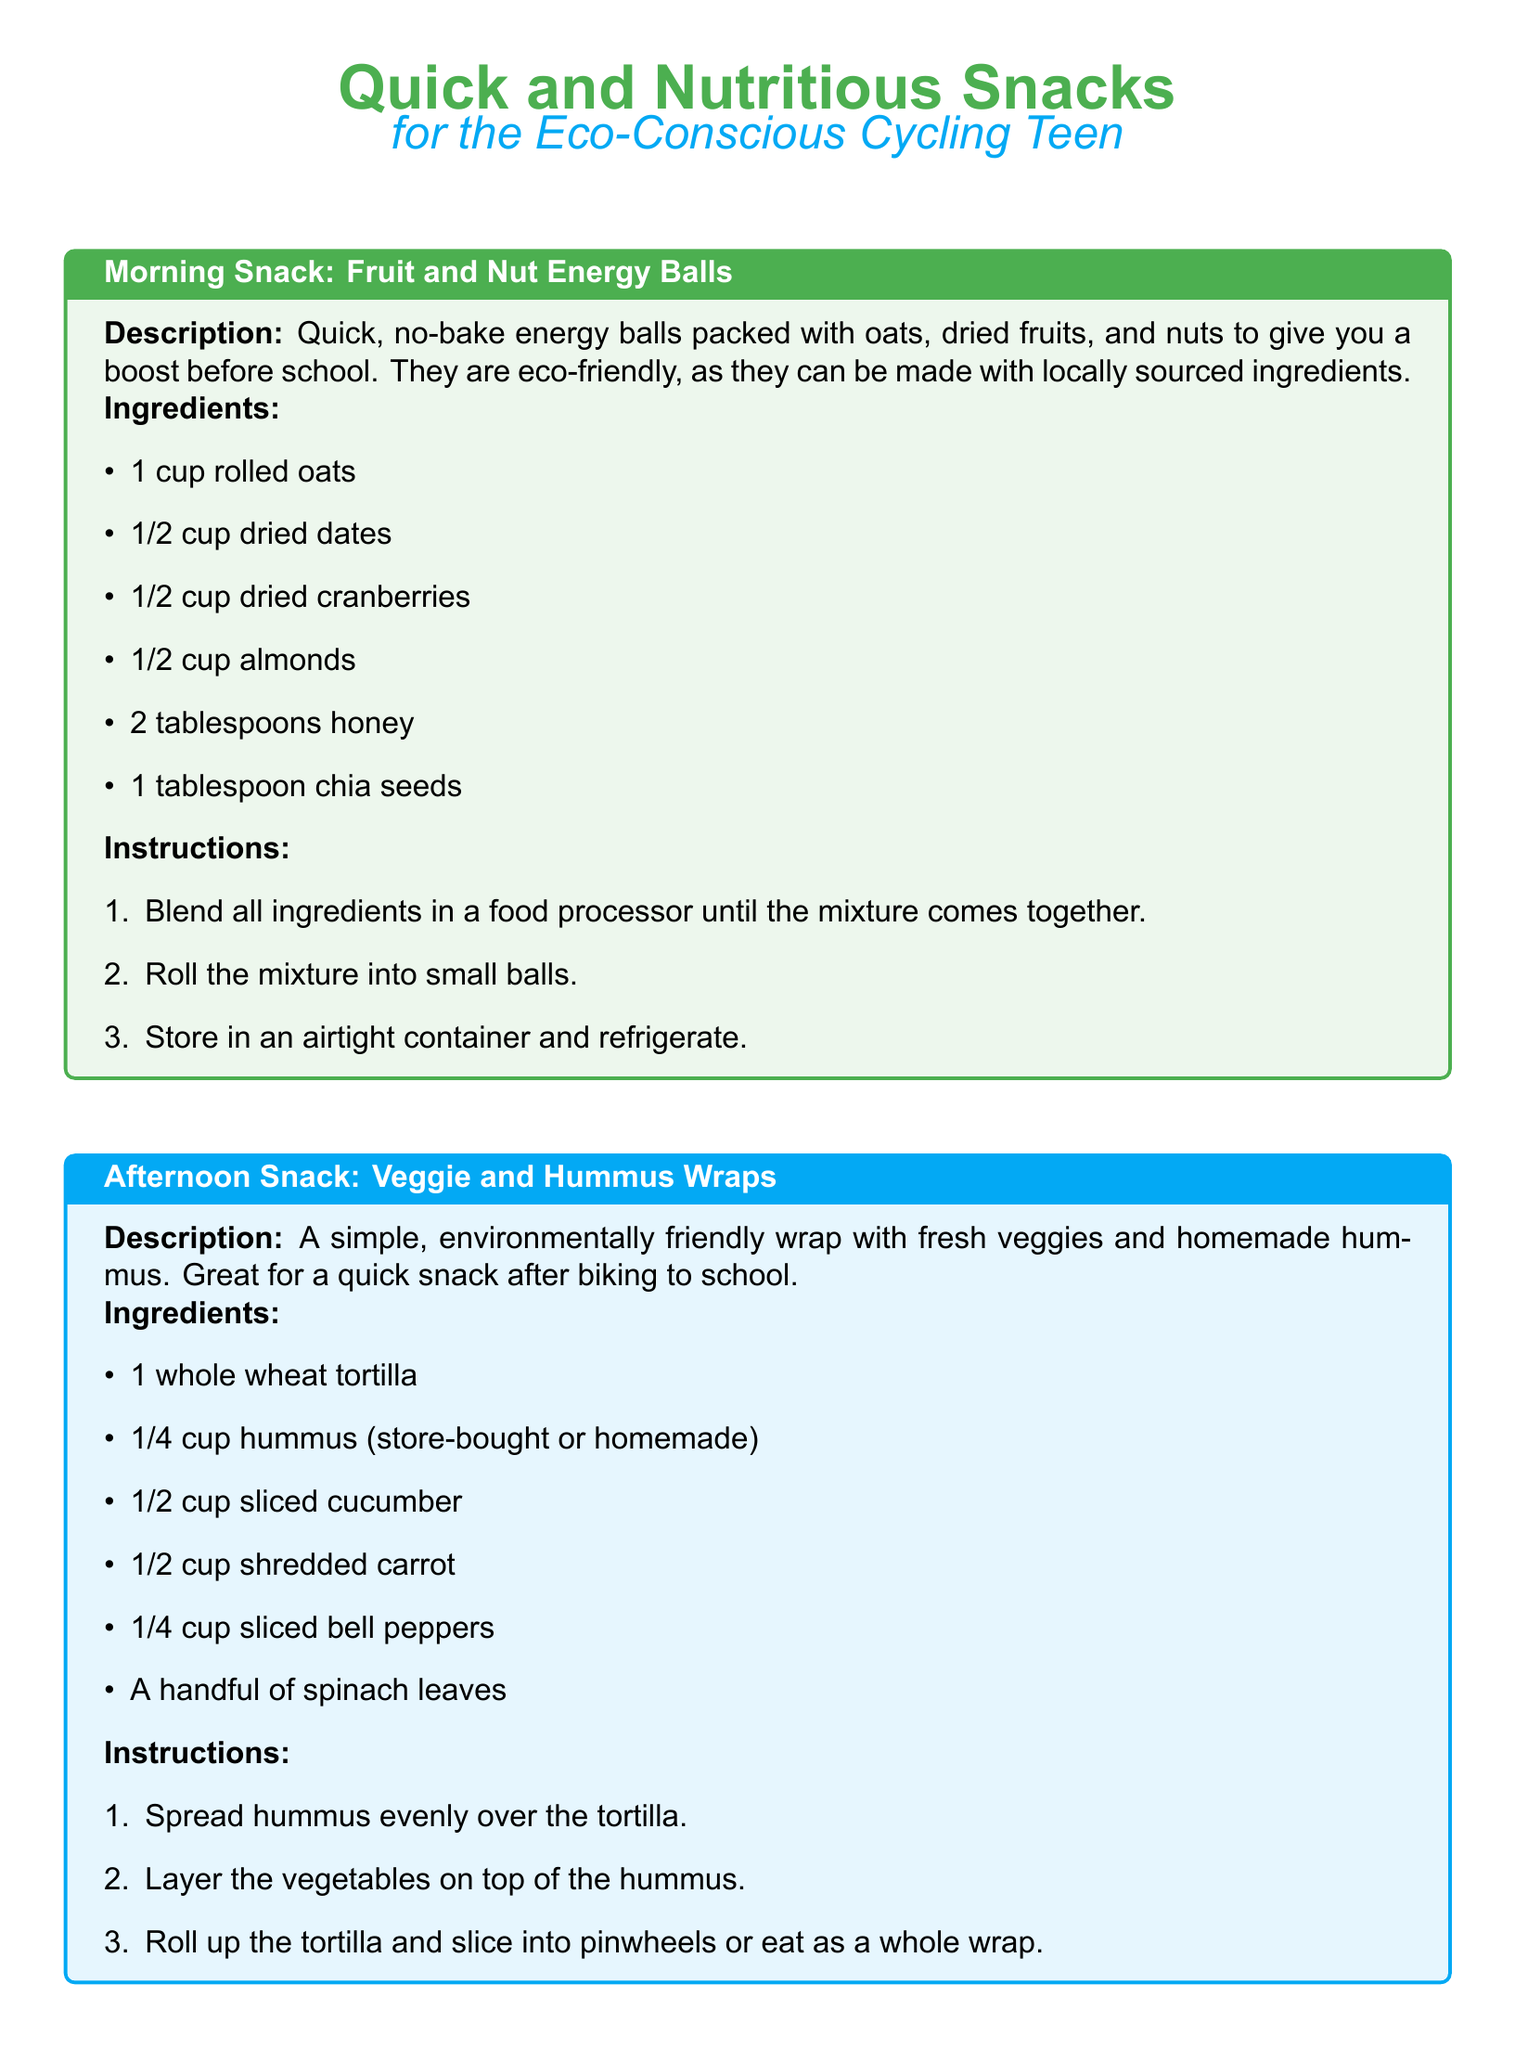What are the ingredients of the morning snack? The morning snack ingredients are listed under the respective section in the document, specifically 1 cup rolled oats, 1/2 cup dried dates, 1/2 cup dried cranberries, 1/2 cup almonds, 2 tablespoons honey, and 1 tablespoon chia seeds.
Answer: 1 cup rolled oats, 1/2 cup dried dates, 1/2 cup dried cranberries, 1/2 cup almonds, 2 tablespoons honey, 1 tablespoon chia seeds How many steps are there in the instructions for the afternoon snack? The afternoon snack instructions outline the number of steps to follow, which include three specific actions.
Answer: 3 What is the main protein source in the evening snack? The evening snack details its components, highlighting Greek yogurt as the primary source of protein.
Answer: Greek yogurt What color is used for the background of the afternoon snack box? The document specifies the background color of the afternoon snack box as a light shade of blue.
Answer: bikeblue!10 What can be added to the Greek yogurt for sweetness? The ingredients for the evening snack mention honey as an addition to the yogurt for sweetness.
Answer: Honey Which wrap is suggested for an afternoon snack? The document explicitly names the whole wheat tortilla as the wrap used in the afternoon snack.
Answer: whole wheat tortilla What type of snack are the recipe boxes designed for? The document lists each recipe box under the theme of quick and nutritious snacks for busy cyclists.
Answer: Quick and Nutritious Snacks 